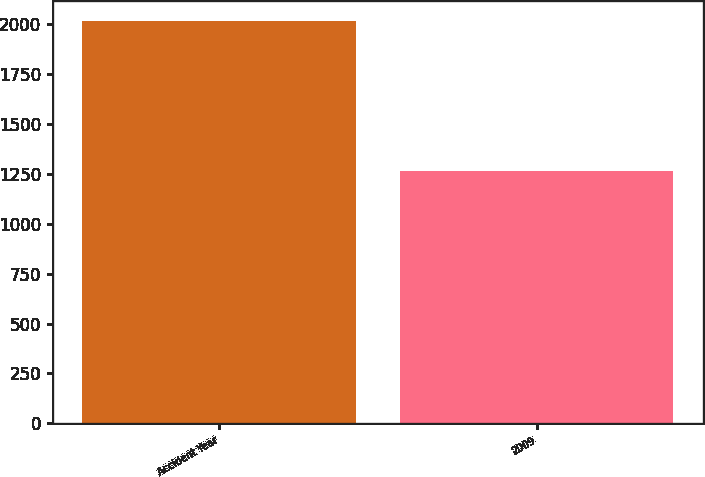Convert chart to OTSL. <chart><loc_0><loc_0><loc_500><loc_500><bar_chart><fcel>Accident Year<fcel>2009<nl><fcel>2018<fcel>1263<nl></chart> 